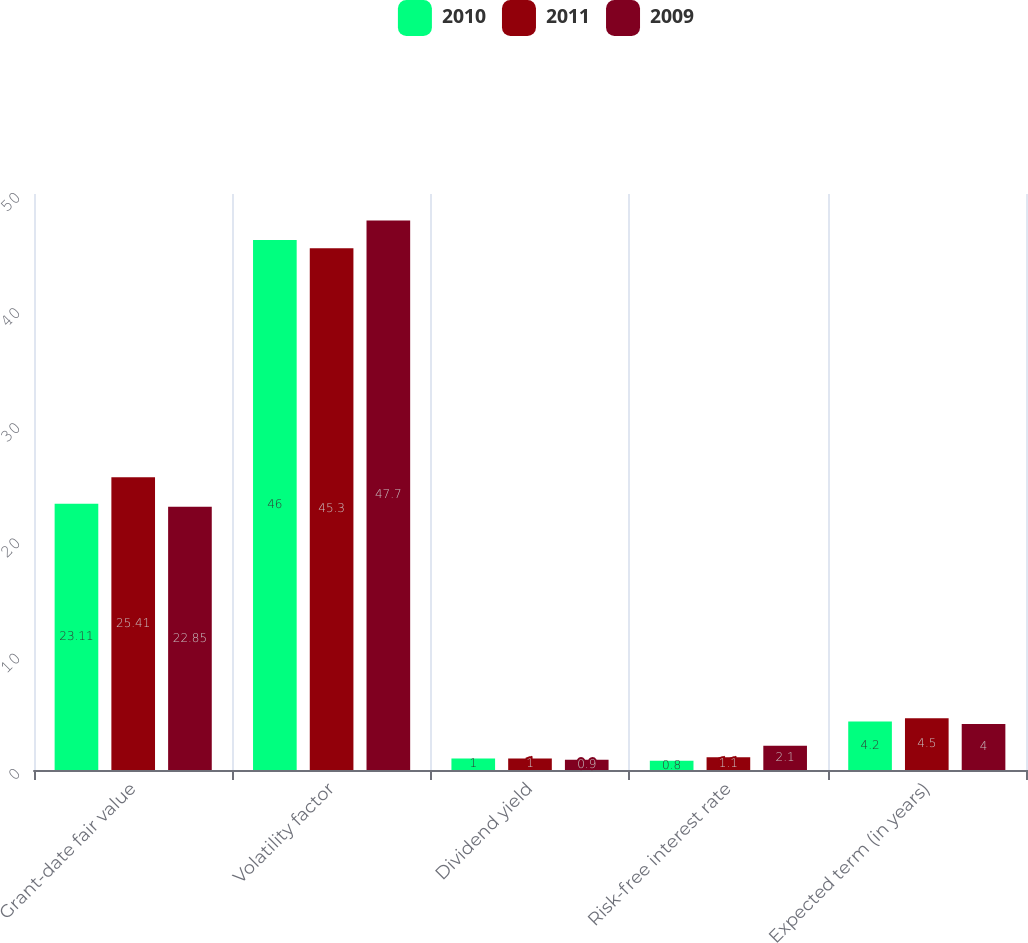Convert chart. <chart><loc_0><loc_0><loc_500><loc_500><stacked_bar_chart><ecel><fcel>Grant-date fair value<fcel>Volatility factor<fcel>Dividend yield<fcel>Risk-free interest rate<fcel>Expected term (in years)<nl><fcel>2010<fcel>23.11<fcel>46<fcel>1<fcel>0.8<fcel>4.2<nl><fcel>2011<fcel>25.41<fcel>45.3<fcel>1<fcel>1.1<fcel>4.5<nl><fcel>2009<fcel>22.85<fcel>47.7<fcel>0.9<fcel>2.1<fcel>4<nl></chart> 